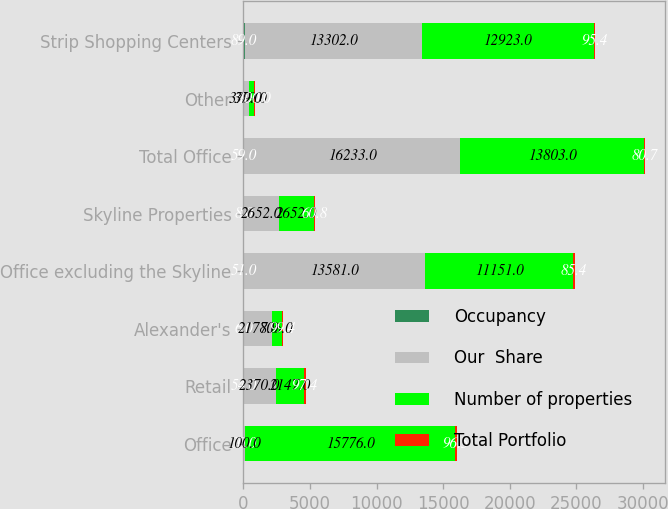Convert chart to OTSL. <chart><loc_0><loc_0><loc_500><loc_500><stacked_bar_chart><ecel><fcel>Office<fcel>Retail<fcel>Alexander's<fcel>Office excluding the Skyline<fcel>Skyline Properties<fcel>Total Office<fcel>Other<fcel>Strip Shopping Centers<nl><fcel>Occupancy<fcel>30<fcel>54<fcel>6<fcel>51<fcel>8<fcel>59<fcel>5<fcel>89<nl><fcel>Our  Share<fcel>100<fcel>2370<fcel>2178<fcel>13581<fcel>2652<fcel>16233<fcel>379<fcel>13302<nl><fcel>Number of properties<fcel>15776<fcel>2147<fcel>706<fcel>11151<fcel>2652<fcel>13803<fcel>379<fcel>12923<nl><fcel>Total Portfolio<fcel>96.5<fcel>97.4<fcel>99.4<fcel>85.4<fcel>60.8<fcel>80.7<fcel>100<fcel>95.4<nl></chart> 